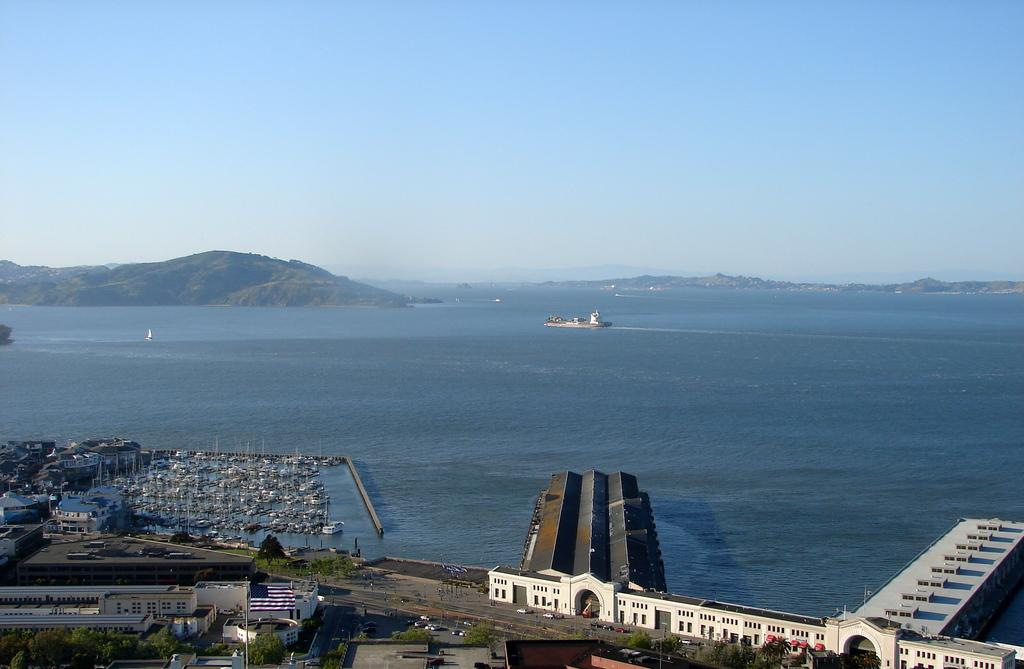What is the primary element visible in the image? There is water in the image. What structures can be seen in the image? There are buildings in the image. What type of vegetation is present in the image? There are trees in the image. What mode of transportation can be seen in the image? There are vehicles and boats in the image. What other objects are present in the image? There are poles in the image. What geographical feature can be seen in the image? There are hills in the image. What is visible in the background of the image? The sky is visible in the background of the image. What time of day is it in the image, as indicated by the flag? There is no flag present in the image, so it is not possible to determine the time of day based on a flag. 